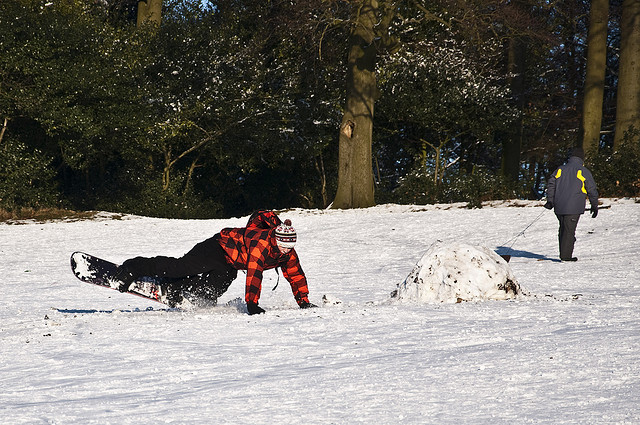<image>What is the man dragging? I am not sure what the man is dragging. It can be a sled, skateboard or snowboard. What is the man dragging? It is ambiguous what the man is dragging. It can be a sled, skateboard, snowboard, or something else. 